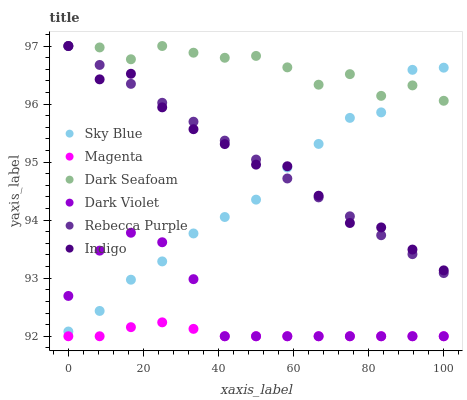Does Magenta have the minimum area under the curve?
Answer yes or no. Yes. Does Dark Seafoam have the maximum area under the curve?
Answer yes or no. Yes. Does Dark Violet have the minimum area under the curve?
Answer yes or no. No. Does Dark Violet have the maximum area under the curve?
Answer yes or no. No. Is Rebecca Purple the smoothest?
Answer yes or no. Yes. Is Dark Seafoam the roughest?
Answer yes or no. Yes. Is Dark Violet the smoothest?
Answer yes or no. No. Is Dark Violet the roughest?
Answer yes or no. No. Does Dark Violet have the lowest value?
Answer yes or no. Yes. Does Dark Seafoam have the lowest value?
Answer yes or no. No. Does Rebecca Purple have the highest value?
Answer yes or no. Yes. Does Dark Violet have the highest value?
Answer yes or no. No. Is Dark Violet less than Indigo?
Answer yes or no. Yes. Is Dark Seafoam greater than Magenta?
Answer yes or no. Yes. Does Dark Violet intersect Magenta?
Answer yes or no. Yes. Is Dark Violet less than Magenta?
Answer yes or no. No. Is Dark Violet greater than Magenta?
Answer yes or no. No. Does Dark Violet intersect Indigo?
Answer yes or no. No. 